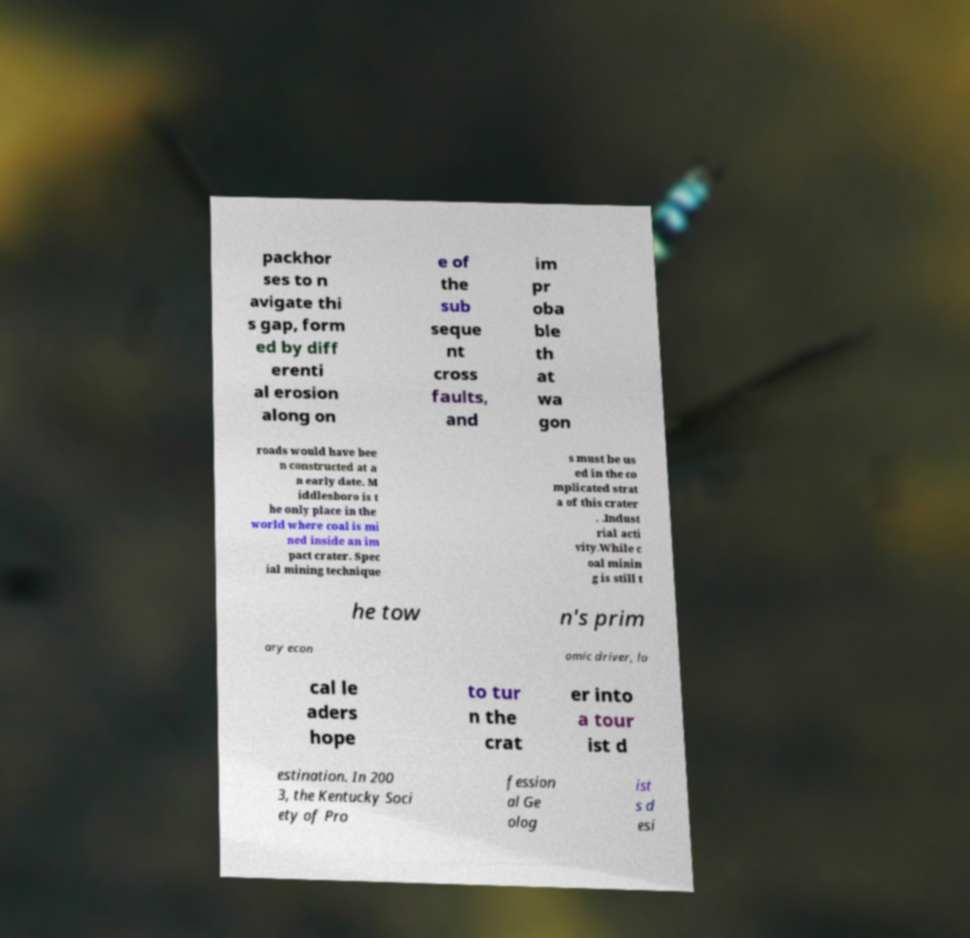Please read and relay the text visible in this image. What does it say? packhor ses to n avigate thi s gap, form ed by diff erenti al erosion along on e of the sub seque nt cross faults, and im pr oba ble th at wa gon roads would have bee n constructed at a n early date. M iddlesboro is t he only place in the world where coal is mi ned inside an im pact crater. Spec ial mining technique s must be us ed in the co mplicated strat a of this crater . .Indust rial acti vity.While c oal minin g is still t he tow n's prim ary econ omic driver, lo cal le aders hope to tur n the crat er into a tour ist d estination. In 200 3, the Kentucky Soci ety of Pro fession al Ge olog ist s d esi 